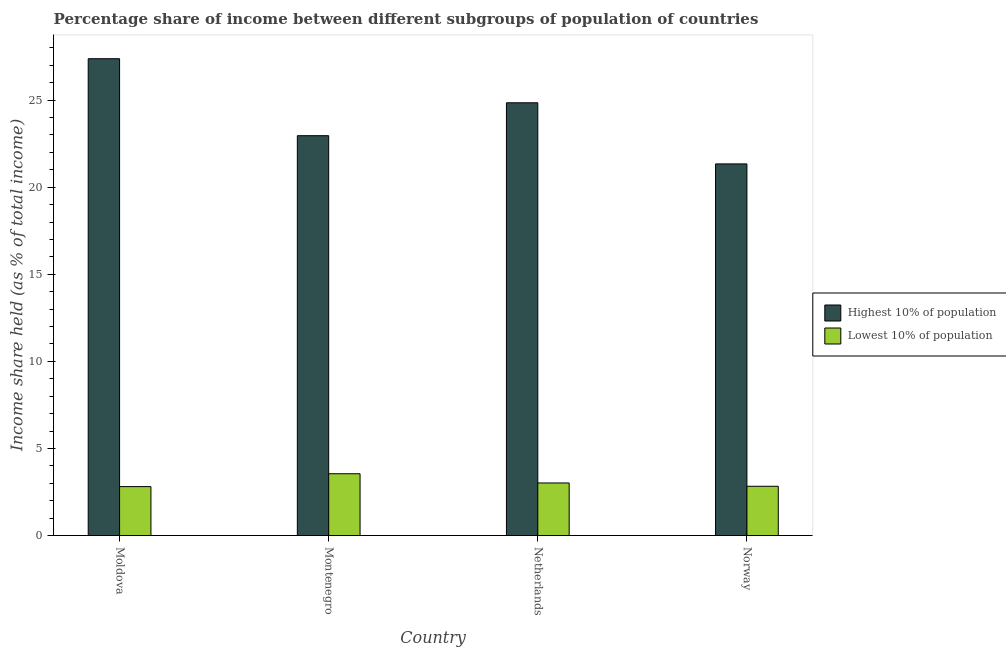How many different coloured bars are there?
Ensure brevity in your answer.  2. How many groups of bars are there?
Offer a terse response. 4. Are the number of bars per tick equal to the number of legend labels?
Provide a succinct answer. Yes. How many bars are there on the 3rd tick from the right?
Provide a succinct answer. 2. What is the label of the 3rd group of bars from the left?
Provide a short and direct response. Netherlands. In how many cases, is the number of bars for a given country not equal to the number of legend labels?
Your answer should be compact. 0. What is the income share held by highest 10% of the population in Norway?
Your answer should be compact. 21.34. Across all countries, what is the maximum income share held by highest 10% of the population?
Make the answer very short. 27.38. Across all countries, what is the minimum income share held by lowest 10% of the population?
Your answer should be compact. 2.81. In which country was the income share held by highest 10% of the population maximum?
Keep it short and to the point. Moldova. In which country was the income share held by lowest 10% of the population minimum?
Keep it short and to the point. Moldova. What is the total income share held by lowest 10% of the population in the graph?
Provide a short and direct response. 12.21. What is the difference between the income share held by lowest 10% of the population in Moldova and that in Montenegro?
Offer a very short reply. -0.74. What is the difference between the income share held by lowest 10% of the population in Norway and the income share held by highest 10% of the population in Netherlands?
Keep it short and to the point. -22.02. What is the average income share held by highest 10% of the population per country?
Your response must be concise. 24.13. What is the difference between the income share held by lowest 10% of the population and income share held by highest 10% of the population in Norway?
Offer a very short reply. -18.51. What is the ratio of the income share held by highest 10% of the population in Montenegro to that in Netherlands?
Provide a short and direct response. 0.92. Is the income share held by lowest 10% of the population in Moldova less than that in Norway?
Give a very brief answer. Yes. Is the difference between the income share held by highest 10% of the population in Moldova and Norway greater than the difference between the income share held by lowest 10% of the population in Moldova and Norway?
Ensure brevity in your answer.  Yes. What is the difference between the highest and the second highest income share held by highest 10% of the population?
Your answer should be compact. 2.53. What is the difference between the highest and the lowest income share held by lowest 10% of the population?
Your answer should be compact. 0.74. In how many countries, is the income share held by lowest 10% of the population greater than the average income share held by lowest 10% of the population taken over all countries?
Provide a short and direct response. 1. What does the 2nd bar from the left in Montenegro represents?
Provide a short and direct response. Lowest 10% of population. What does the 1st bar from the right in Norway represents?
Give a very brief answer. Lowest 10% of population. How many bars are there?
Provide a short and direct response. 8. Are all the bars in the graph horizontal?
Your answer should be compact. No. How many legend labels are there?
Offer a terse response. 2. How are the legend labels stacked?
Your answer should be very brief. Vertical. What is the title of the graph?
Offer a terse response. Percentage share of income between different subgroups of population of countries. Does "Private credit bureau" appear as one of the legend labels in the graph?
Make the answer very short. No. What is the label or title of the Y-axis?
Keep it short and to the point. Income share held (as % of total income). What is the Income share held (as % of total income) in Highest 10% of population in Moldova?
Your answer should be very brief. 27.38. What is the Income share held (as % of total income) of Lowest 10% of population in Moldova?
Your answer should be compact. 2.81. What is the Income share held (as % of total income) of Highest 10% of population in Montenegro?
Give a very brief answer. 22.96. What is the Income share held (as % of total income) of Lowest 10% of population in Montenegro?
Your answer should be very brief. 3.55. What is the Income share held (as % of total income) in Highest 10% of population in Netherlands?
Your answer should be compact. 24.85. What is the Income share held (as % of total income) of Lowest 10% of population in Netherlands?
Provide a short and direct response. 3.02. What is the Income share held (as % of total income) in Highest 10% of population in Norway?
Make the answer very short. 21.34. What is the Income share held (as % of total income) in Lowest 10% of population in Norway?
Offer a terse response. 2.83. Across all countries, what is the maximum Income share held (as % of total income) of Highest 10% of population?
Ensure brevity in your answer.  27.38. Across all countries, what is the maximum Income share held (as % of total income) of Lowest 10% of population?
Offer a terse response. 3.55. Across all countries, what is the minimum Income share held (as % of total income) in Highest 10% of population?
Your answer should be compact. 21.34. Across all countries, what is the minimum Income share held (as % of total income) in Lowest 10% of population?
Your answer should be very brief. 2.81. What is the total Income share held (as % of total income) of Highest 10% of population in the graph?
Offer a terse response. 96.53. What is the total Income share held (as % of total income) of Lowest 10% of population in the graph?
Provide a short and direct response. 12.21. What is the difference between the Income share held (as % of total income) of Highest 10% of population in Moldova and that in Montenegro?
Ensure brevity in your answer.  4.42. What is the difference between the Income share held (as % of total income) in Lowest 10% of population in Moldova and that in Montenegro?
Provide a short and direct response. -0.74. What is the difference between the Income share held (as % of total income) in Highest 10% of population in Moldova and that in Netherlands?
Provide a succinct answer. 2.53. What is the difference between the Income share held (as % of total income) of Lowest 10% of population in Moldova and that in Netherlands?
Offer a very short reply. -0.21. What is the difference between the Income share held (as % of total income) of Highest 10% of population in Moldova and that in Norway?
Provide a succinct answer. 6.04. What is the difference between the Income share held (as % of total income) of Lowest 10% of population in Moldova and that in Norway?
Provide a short and direct response. -0.02. What is the difference between the Income share held (as % of total income) of Highest 10% of population in Montenegro and that in Netherlands?
Your answer should be compact. -1.89. What is the difference between the Income share held (as % of total income) of Lowest 10% of population in Montenegro and that in Netherlands?
Your response must be concise. 0.53. What is the difference between the Income share held (as % of total income) in Highest 10% of population in Montenegro and that in Norway?
Provide a succinct answer. 1.62. What is the difference between the Income share held (as % of total income) in Lowest 10% of population in Montenegro and that in Norway?
Keep it short and to the point. 0.72. What is the difference between the Income share held (as % of total income) of Highest 10% of population in Netherlands and that in Norway?
Provide a succinct answer. 3.51. What is the difference between the Income share held (as % of total income) in Lowest 10% of population in Netherlands and that in Norway?
Ensure brevity in your answer.  0.19. What is the difference between the Income share held (as % of total income) in Highest 10% of population in Moldova and the Income share held (as % of total income) in Lowest 10% of population in Montenegro?
Your answer should be compact. 23.83. What is the difference between the Income share held (as % of total income) of Highest 10% of population in Moldova and the Income share held (as % of total income) of Lowest 10% of population in Netherlands?
Make the answer very short. 24.36. What is the difference between the Income share held (as % of total income) of Highest 10% of population in Moldova and the Income share held (as % of total income) of Lowest 10% of population in Norway?
Your answer should be very brief. 24.55. What is the difference between the Income share held (as % of total income) in Highest 10% of population in Montenegro and the Income share held (as % of total income) in Lowest 10% of population in Netherlands?
Give a very brief answer. 19.94. What is the difference between the Income share held (as % of total income) of Highest 10% of population in Montenegro and the Income share held (as % of total income) of Lowest 10% of population in Norway?
Ensure brevity in your answer.  20.13. What is the difference between the Income share held (as % of total income) in Highest 10% of population in Netherlands and the Income share held (as % of total income) in Lowest 10% of population in Norway?
Provide a short and direct response. 22.02. What is the average Income share held (as % of total income) in Highest 10% of population per country?
Your answer should be very brief. 24.13. What is the average Income share held (as % of total income) in Lowest 10% of population per country?
Your response must be concise. 3.05. What is the difference between the Income share held (as % of total income) of Highest 10% of population and Income share held (as % of total income) of Lowest 10% of population in Moldova?
Provide a succinct answer. 24.57. What is the difference between the Income share held (as % of total income) in Highest 10% of population and Income share held (as % of total income) in Lowest 10% of population in Montenegro?
Ensure brevity in your answer.  19.41. What is the difference between the Income share held (as % of total income) of Highest 10% of population and Income share held (as % of total income) of Lowest 10% of population in Netherlands?
Your response must be concise. 21.83. What is the difference between the Income share held (as % of total income) in Highest 10% of population and Income share held (as % of total income) in Lowest 10% of population in Norway?
Your answer should be very brief. 18.51. What is the ratio of the Income share held (as % of total income) of Highest 10% of population in Moldova to that in Montenegro?
Provide a succinct answer. 1.19. What is the ratio of the Income share held (as % of total income) in Lowest 10% of population in Moldova to that in Montenegro?
Ensure brevity in your answer.  0.79. What is the ratio of the Income share held (as % of total income) of Highest 10% of population in Moldova to that in Netherlands?
Your answer should be compact. 1.1. What is the ratio of the Income share held (as % of total income) of Lowest 10% of population in Moldova to that in Netherlands?
Provide a short and direct response. 0.93. What is the ratio of the Income share held (as % of total income) in Highest 10% of population in Moldova to that in Norway?
Give a very brief answer. 1.28. What is the ratio of the Income share held (as % of total income) of Lowest 10% of population in Moldova to that in Norway?
Keep it short and to the point. 0.99. What is the ratio of the Income share held (as % of total income) in Highest 10% of population in Montenegro to that in Netherlands?
Give a very brief answer. 0.92. What is the ratio of the Income share held (as % of total income) of Lowest 10% of population in Montenegro to that in Netherlands?
Keep it short and to the point. 1.18. What is the ratio of the Income share held (as % of total income) of Highest 10% of population in Montenegro to that in Norway?
Your response must be concise. 1.08. What is the ratio of the Income share held (as % of total income) in Lowest 10% of population in Montenegro to that in Norway?
Offer a very short reply. 1.25. What is the ratio of the Income share held (as % of total income) in Highest 10% of population in Netherlands to that in Norway?
Your answer should be compact. 1.16. What is the ratio of the Income share held (as % of total income) in Lowest 10% of population in Netherlands to that in Norway?
Your answer should be compact. 1.07. What is the difference between the highest and the second highest Income share held (as % of total income) of Highest 10% of population?
Ensure brevity in your answer.  2.53. What is the difference between the highest and the second highest Income share held (as % of total income) in Lowest 10% of population?
Your answer should be compact. 0.53. What is the difference between the highest and the lowest Income share held (as % of total income) of Highest 10% of population?
Your response must be concise. 6.04. What is the difference between the highest and the lowest Income share held (as % of total income) of Lowest 10% of population?
Provide a short and direct response. 0.74. 